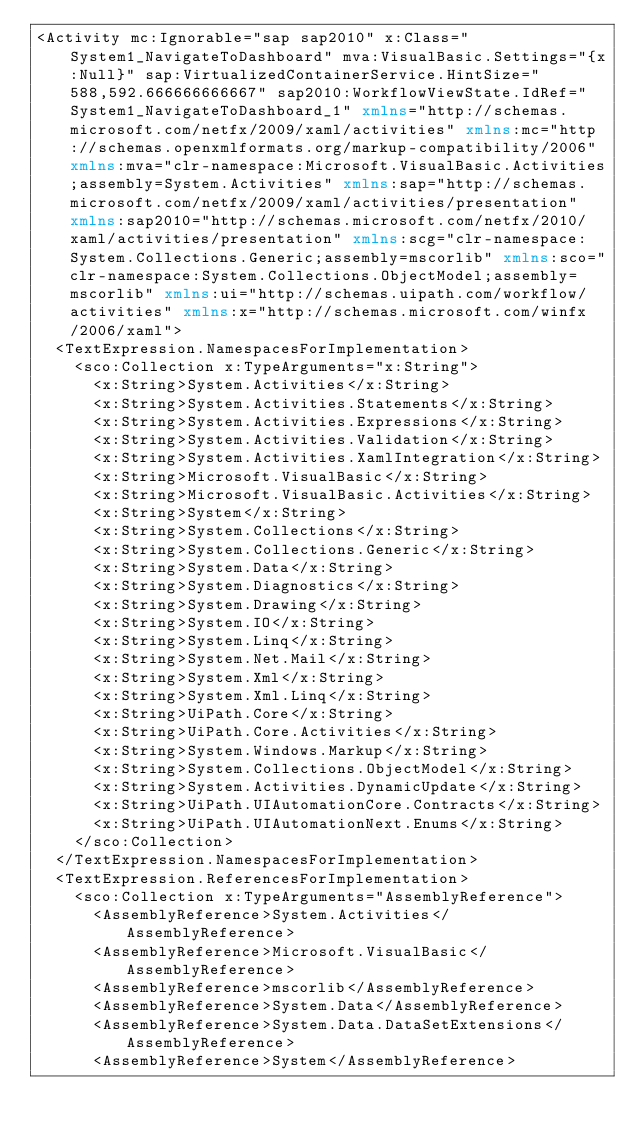<code> <loc_0><loc_0><loc_500><loc_500><_XML_><Activity mc:Ignorable="sap sap2010" x:Class="System1_NavigateToDashboard" mva:VisualBasic.Settings="{x:Null}" sap:VirtualizedContainerService.HintSize="588,592.666666666667" sap2010:WorkflowViewState.IdRef="System1_NavigateToDashboard_1" xmlns="http://schemas.microsoft.com/netfx/2009/xaml/activities" xmlns:mc="http://schemas.openxmlformats.org/markup-compatibility/2006" xmlns:mva="clr-namespace:Microsoft.VisualBasic.Activities;assembly=System.Activities" xmlns:sap="http://schemas.microsoft.com/netfx/2009/xaml/activities/presentation" xmlns:sap2010="http://schemas.microsoft.com/netfx/2010/xaml/activities/presentation" xmlns:scg="clr-namespace:System.Collections.Generic;assembly=mscorlib" xmlns:sco="clr-namespace:System.Collections.ObjectModel;assembly=mscorlib" xmlns:ui="http://schemas.uipath.com/workflow/activities" xmlns:x="http://schemas.microsoft.com/winfx/2006/xaml">
  <TextExpression.NamespacesForImplementation>
    <sco:Collection x:TypeArguments="x:String">
      <x:String>System.Activities</x:String>
      <x:String>System.Activities.Statements</x:String>
      <x:String>System.Activities.Expressions</x:String>
      <x:String>System.Activities.Validation</x:String>
      <x:String>System.Activities.XamlIntegration</x:String>
      <x:String>Microsoft.VisualBasic</x:String>
      <x:String>Microsoft.VisualBasic.Activities</x:String>
      <x:String>System</x:String>
      <x:String>System.Collections</x:String>
      <x:String>System.Collections.Generic</x:String>
      <x:String>System.Data</x:String>
      <x:String>System.Diagnostics</x:String>
      <x:String>System.Drawing</x:String>
      <x:String>System.IO</x:String>
      <x:String>System.Linq</x:String>
      <x:String>System.Net.Mail</x:String>
      <x:String>System.Xml</x:String>
      <x:String>System.Xml.Linq</x:String>
      <x:String>UiPath.Core</x:String>
      <x:String>UiPath.Core.Activities</x:String>
      <x:String>System.Windows.Markup</x:String>
      <x:String>System.Collections.ObjectModel</x:String>
      <x:String>System.Activities.DynamicUpdate</x:String>
      <x:String>UiPath.UIAutomationCore.Contracts</x:String>
      <x:String>UiPath.UIAutomationNext.Enums</x:String>
    </sco:Collection>
  </TextExpression.NamespacesForImplementation>
  <TextExpression.ReferencesForImplementation>
    <sco:Collection x:TypeArguments="AssemblyReference">
      <AssemblyReference>System.Activities</AssemblyReference>
      <AssemblyReference>Microsoft.VisualBasic</AssemblyReference>
      <AssemblyReference>mscorlib</AssemblyReference>
      <AssemblyReference>System.Data</AssemblyReference>
      <AssemblyReference>System.Data.DataSetExtensions</AssemblyReference>
      <AssemblyReference>System</AssemblyReference></code> 